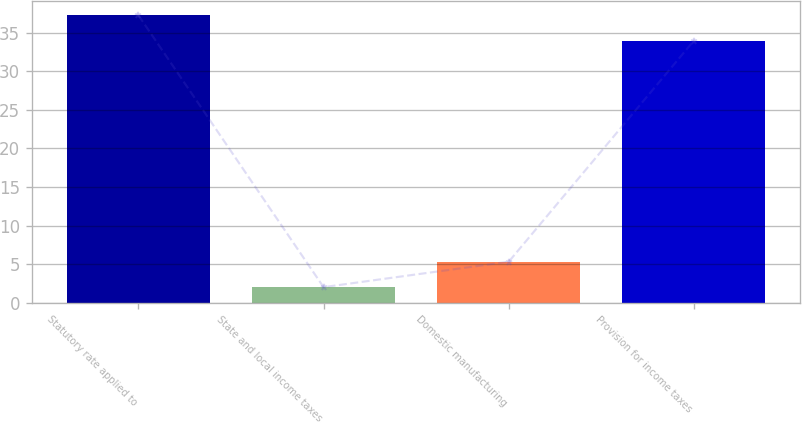Convert chart to OTSL. <chart><loc_0><loc_0><loc_500><loc_500><bar_chart><fcel>Statutory rate applied to<fcel>State and local income taxes<fcel>Domestic manufacturing<fcel>Provision for income taxes<nl><fcel>37.3<fcel>2<fcel>5.3<fcel>34<nl></chart> 